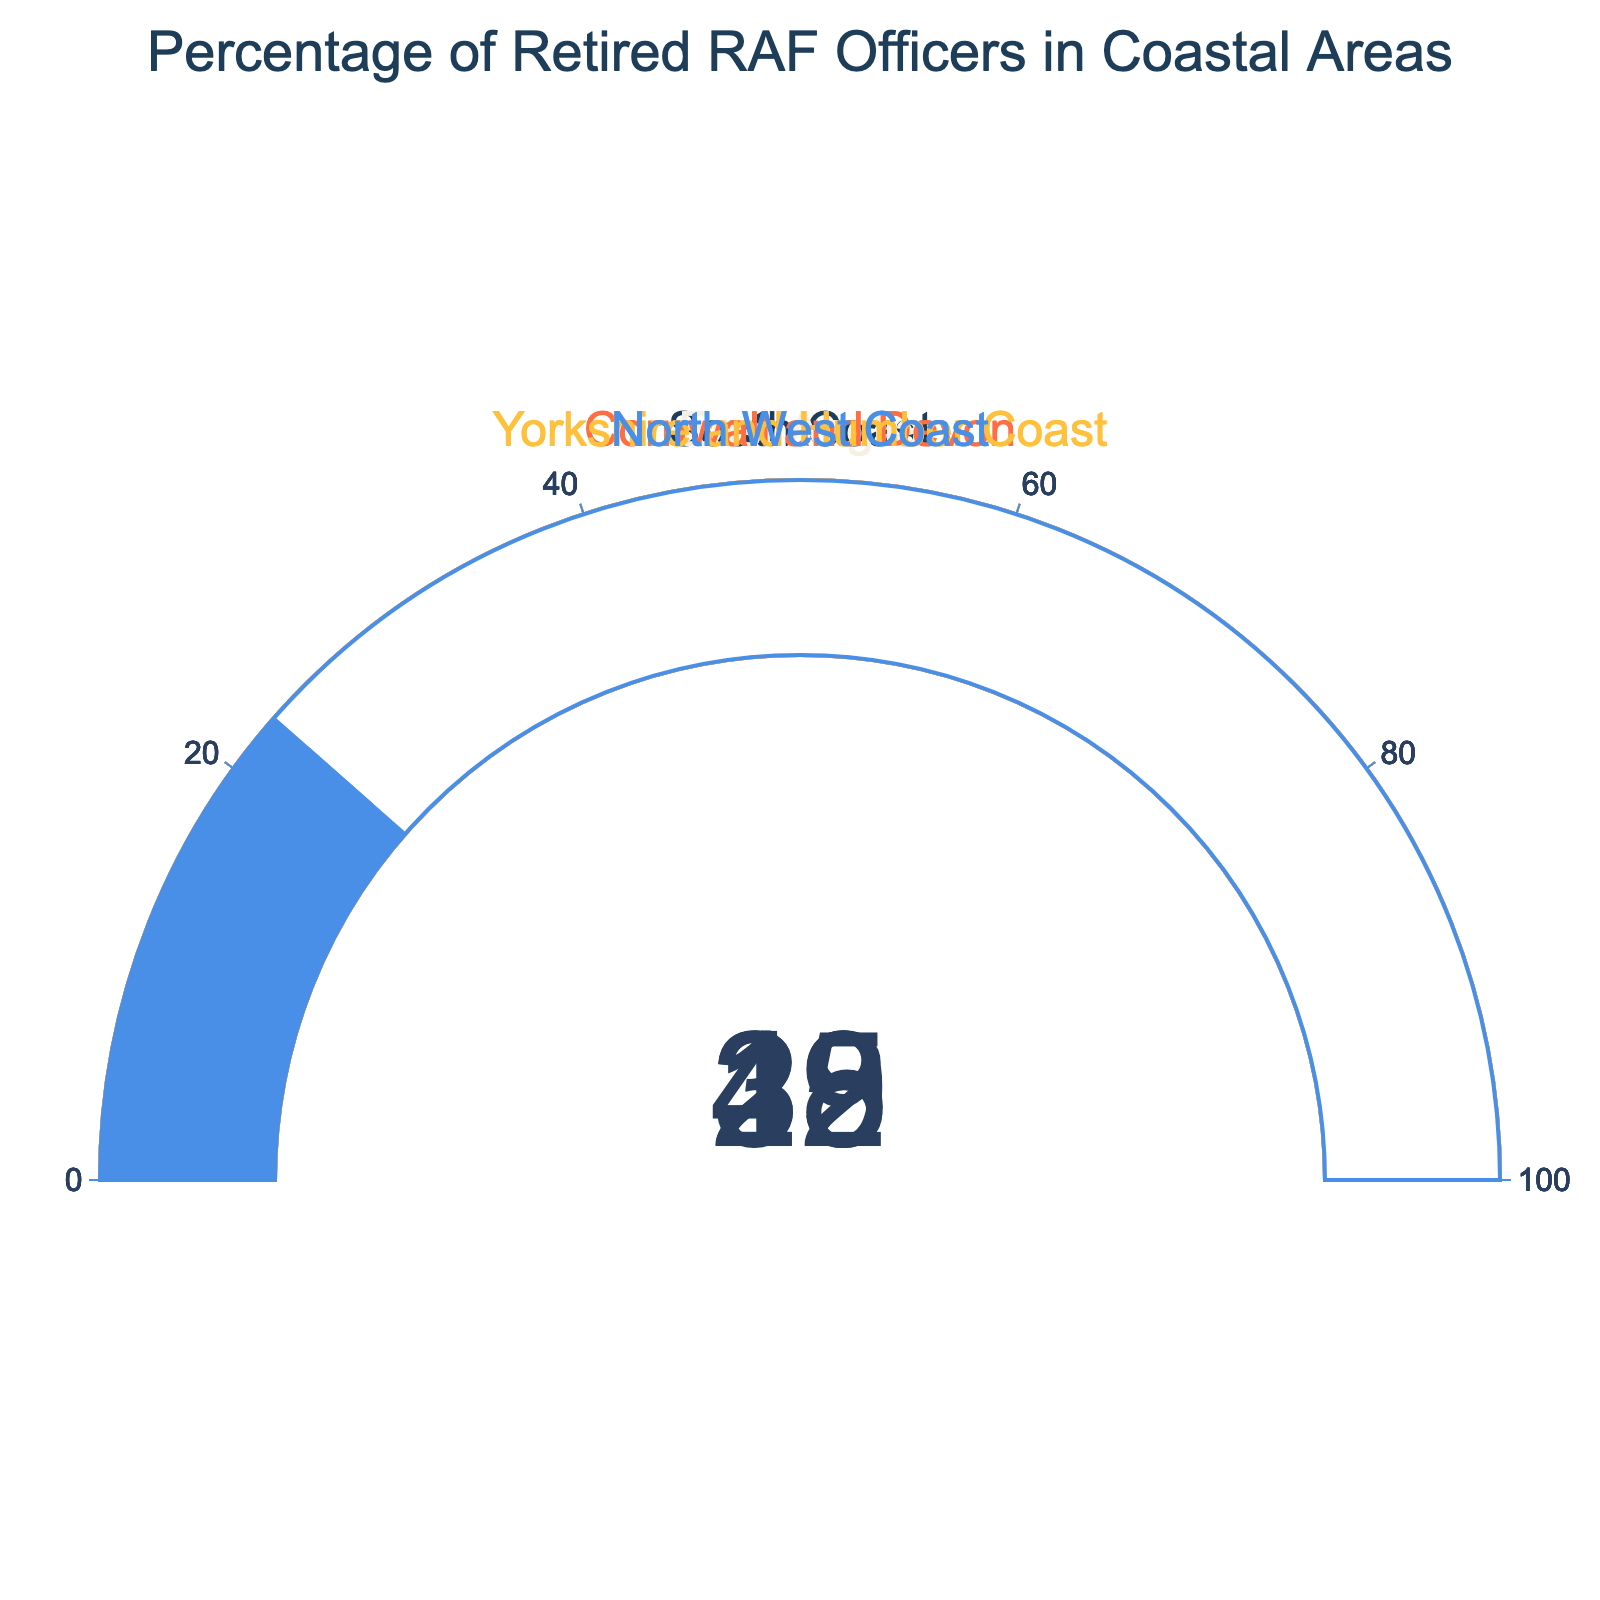What's the highest percentage of retired RAF officers living in coastal areas? The gauge chart indicates various percentages for different coastal regions. The highest percentage of retired RAF officers is displayed by the region with the gauge needle closest to the maximum range. In this case, the South Coast has the highest percentage at 42.
Answer: 42 What's the difference in percentage between Cornwall and Devon and the North West Coast? The gauge chart shows the percentage for Cornwall and Devon as 35 and for the North West Coast as 23. The difference is calculated by subtracting the smaller percentage from the larger one: 35 - 23 = 12.
Answer: 12 Which region has the lowest percentage of retired RAF officers? By examining the gauge chart and comparing the values displayed on each gauge, the Yorkshire and Humber Coast has the lowest percentage at 19.
Answer: Yorkshire and Humber Coast What is the combined percentage of the East Anglia and Yorkshire and Humber Coast regions? To find the combined percentage, sum the percentages for East Anglia (28) and Yorkshire and Humber Coast (19). The calculation is: 28 + 19 = 47.
Answer: 47 Is the percentage of retired RAF officers living in Cornwall and Devon higher than in the North West Coast? The gauge for Cornwall and Devon shows 35, while the North West Coast shows 23. Since 35 is greater than 23, the percentage in Cornwall and Devon is indeed higher.
Answer: Yes What is the average percentage of retired RAF officers across all regions? Add all the percentages together and then divide by the number of regions. The percentages are: 42, 28, 35, 19, and 23. Sum them: 42 + 28 + 35 + 19 + 23 = 147. Divide by the number of regions (5): 147 / 5 = 29.4.
Answer: 29.4 By how much does the percentage for the South Coast exceed that for East Anglia? The percentage for the South Coast is 42 and for East Anglia is 28. Subtract the smaller from the larger: 42 - 28 = 14. The South Coast exceeds East Anglia by 14.
Answer: 14 Are there more regions with percentages above 30 than below 30? The regions above 30 are South Coast (42), Cornwall and Devon (35). The regions below 30 are East Anglia (28), Yorkshire and Humber Coast (19), and North West Coast (23). There are 2 regions above 30 and 3 regions below 30. Thus, no, there are not more regions above 30.
Answer: No 